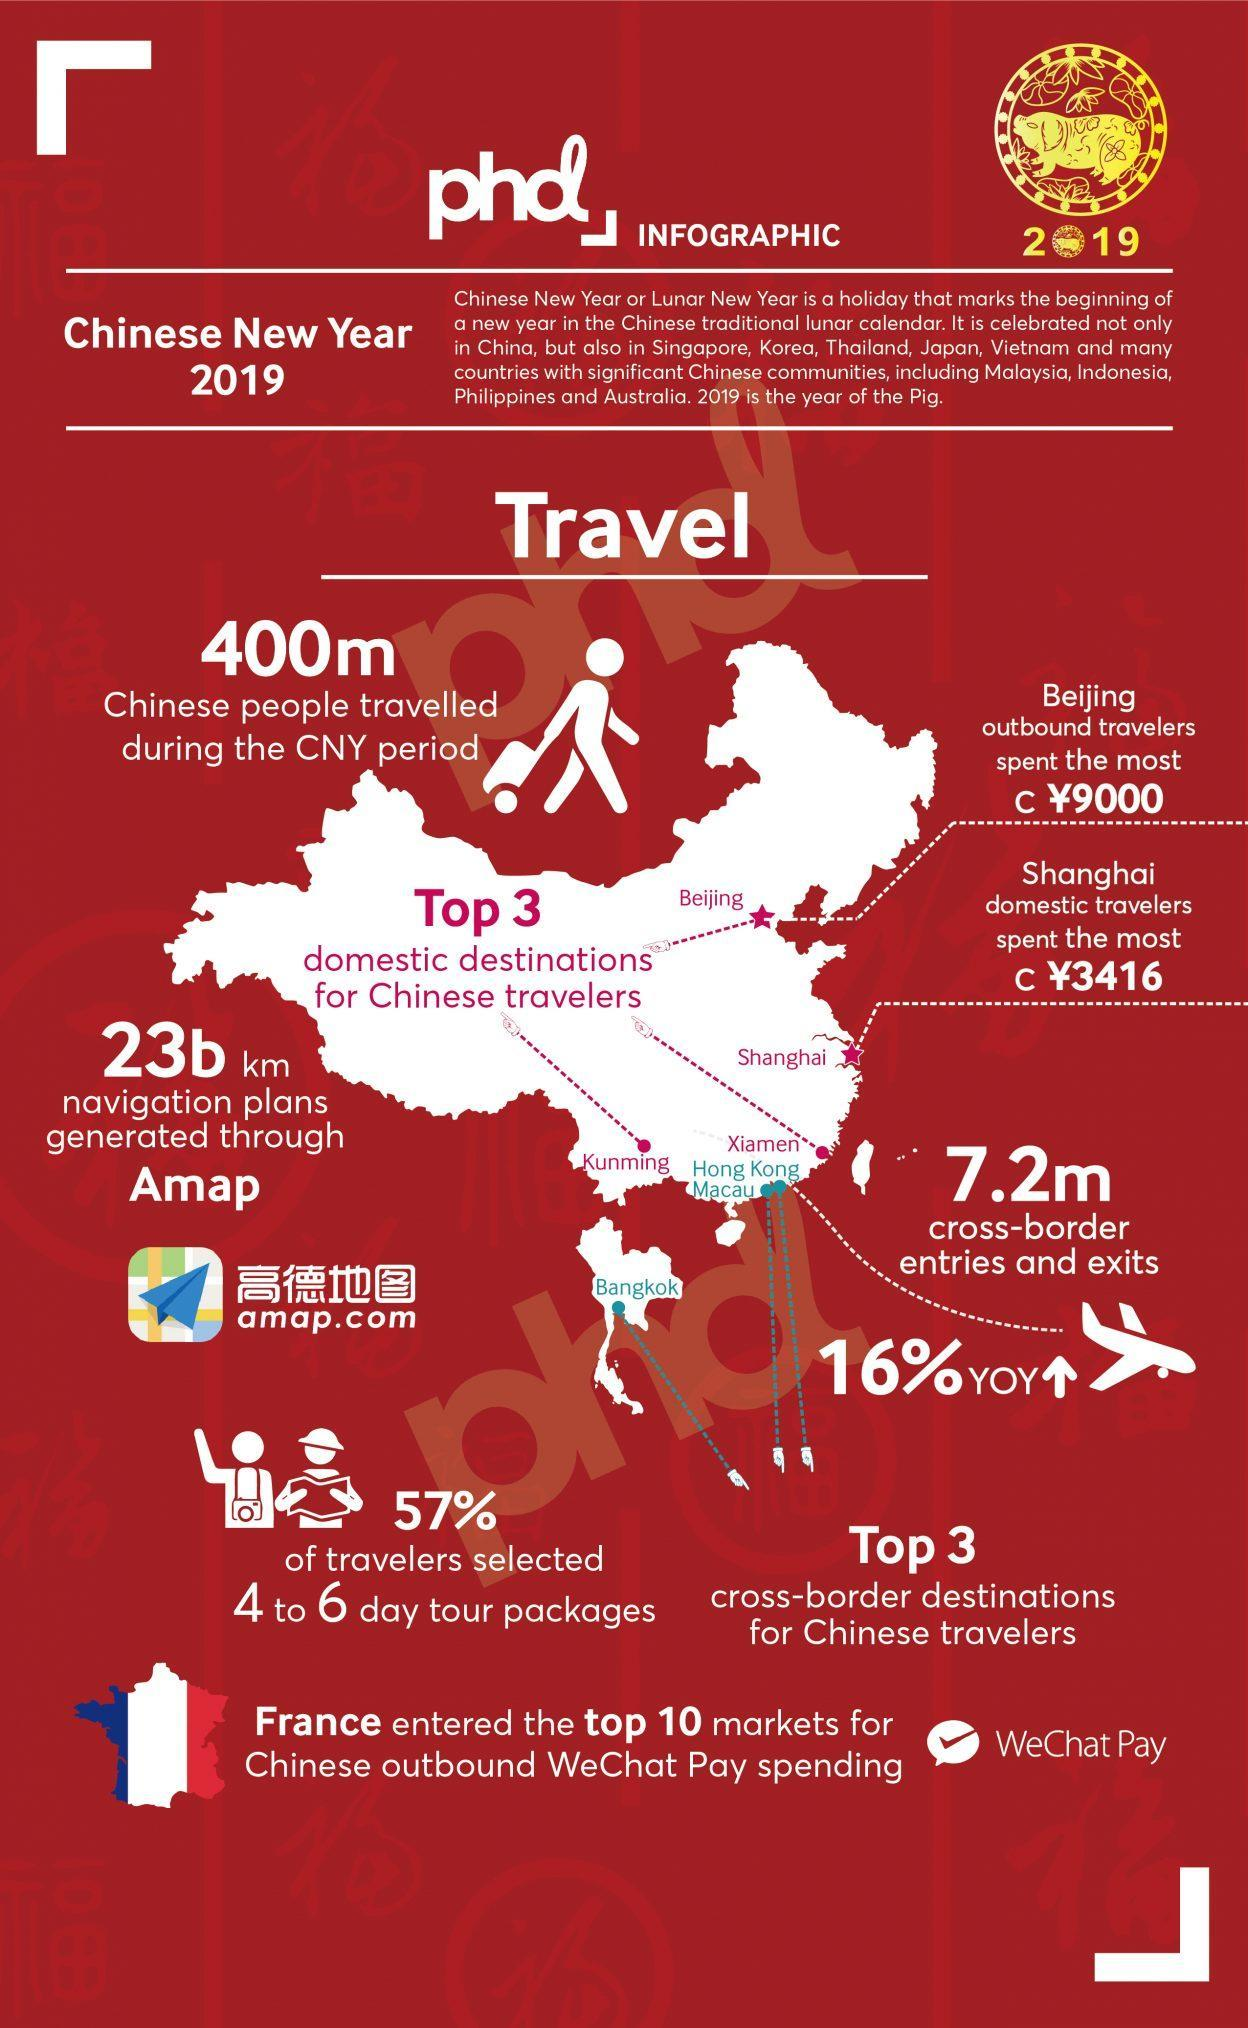Which animal appears on the yellow image ?
Answer the question with a short phrase. pig How many domestic destinations are listed ? 4 What is the total amount spent by outbound travelers from Beijing and Shanghai? 12,416 How many cross border destinations are listed? 3 How many popular destinations are listed on the map? 7 How countries other than China celebrate the Chinese New year? 9 